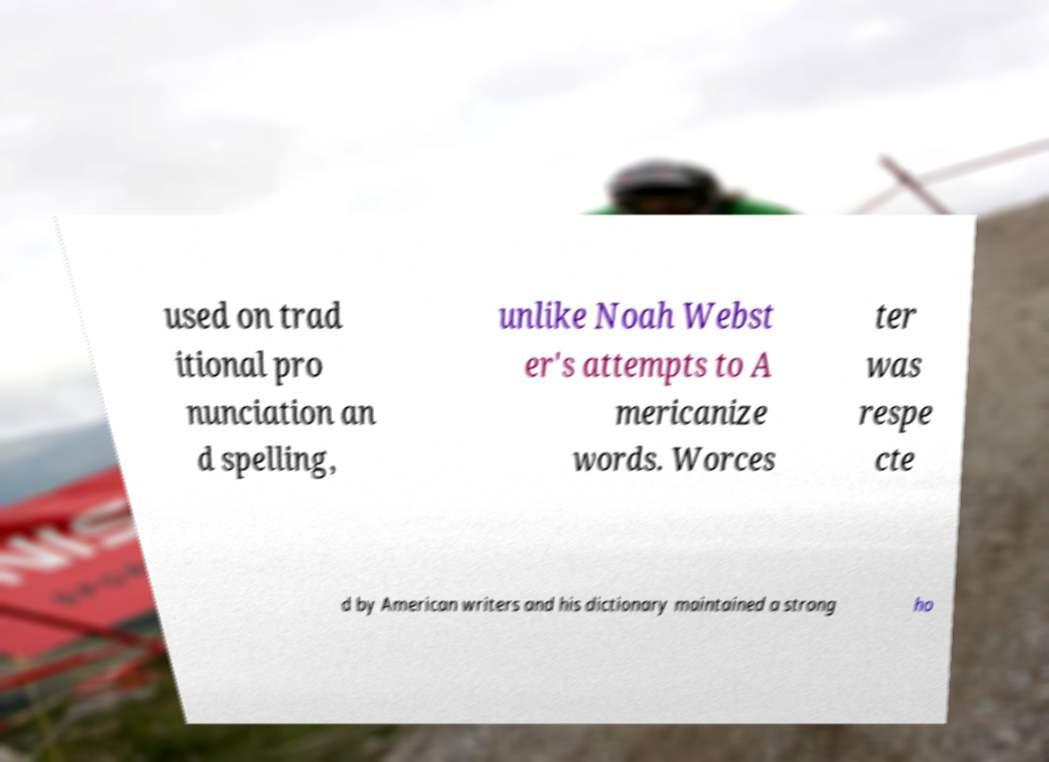There's text embedded in this image that I need extracted. Can you transcribe it verbatim? used on trad itional pro nunciation an d spelling, unlike Noah Webst er's attempts to A mericanize words. Worces ter was respe cte d by American writers and his dictionary maintained a strong ho 